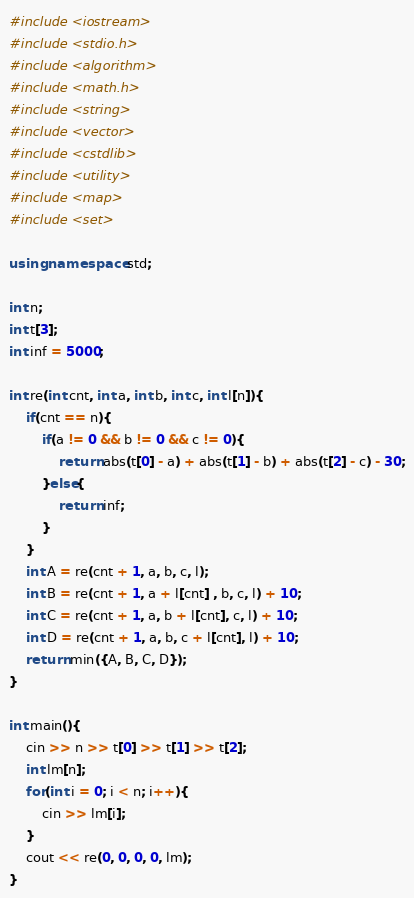Convert code to text. <code><loc_0><loc_0><loc_500><loc_500><_C++_>#include <iostream>
#include <stdio.h>
#include <algorithm>
#include <math.h>
#include <string>
#include <vector>
#include <cstdlib>
#include <utility>
#include <map>
#include <set>

using namespace std;

int n;
int t[3];
int inf = 5000;

int re(int cnt, int a, int b, int c, int l[n]){
    if(cnt == n){
        if(a != 0 && b != 0 && c != 0){
            return abs(t[0] - a) + abs(t[1] - b) + abs(t[2] - c) - 30;
        }else{
            return inf;
        }
    }
    int A = re(cnt + 1, a, b, c, l);
    int B = re(cnt + 1, a + l[cnt] , b, c, l) + 10;
    int C = re(cnt + 1, a, b + l[cnt], c, l) + 10;
    int D = re(cnt + 1, a, b, c + l[cnt], l) + 10;
    return min({A, B, C, D});
}

int main(){
    cin >> n >> t[0] >> t[1] >> t[2];
    int lm[n];
    for(int i = 0; i < n; i++){
        cin >> lm[i];
    }
    cout << re(0, 0, 0, 0, lm);
}
</code> 